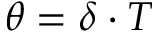Convert formula to latex. <formula><loc_0><loc_0><loc_500><loc_500>\theta = \delta \cdot T</formula> 